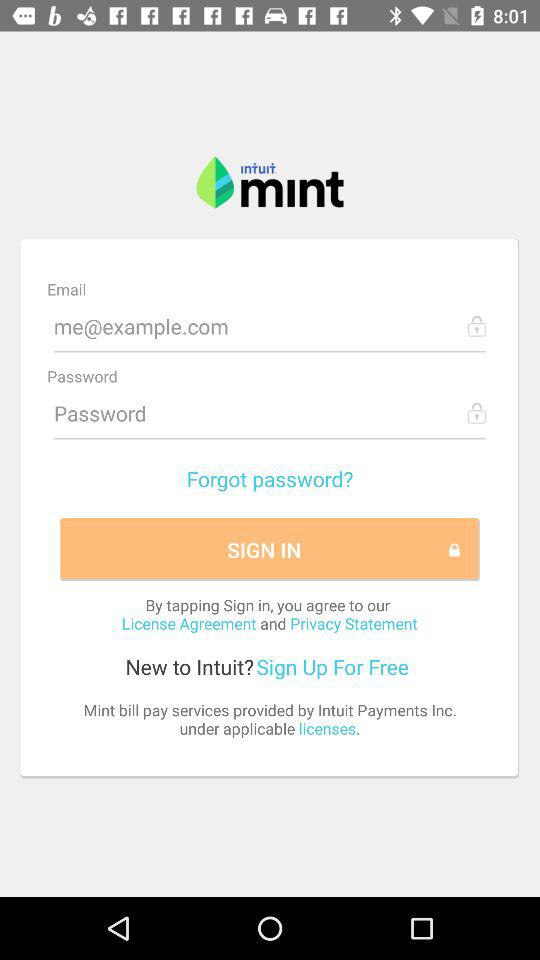What is the name of the application? The name of the application is "Intuit Mint". 